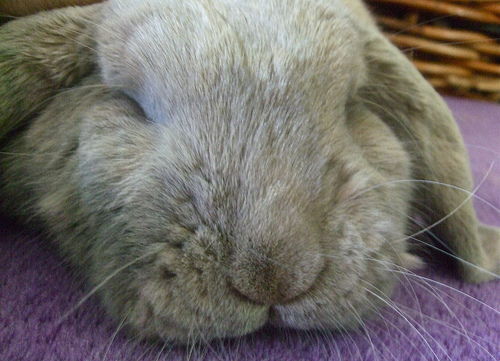<image>
Is the rabbit on the carpet? Yes. Looking at the image, I can see the rabbit is positioned on top of the carpet, with the carpet providing support. 